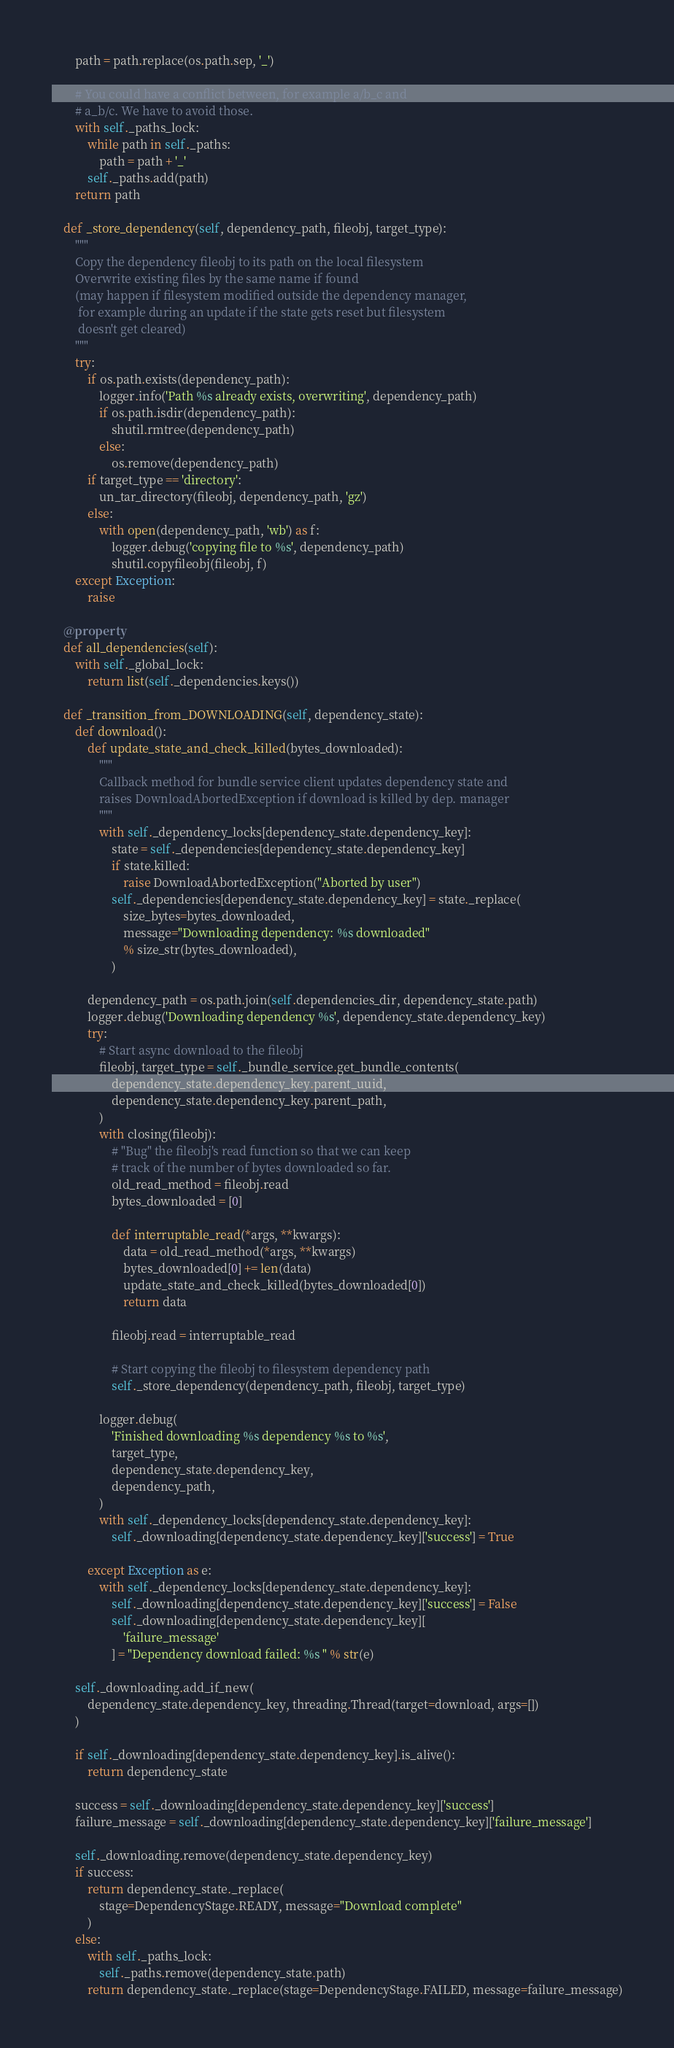<code> <loc_0><loc_0><loc_500><loc_500><_Python_>        path = path.replace(os.path.sep, '_')

        # You could have a conflict between, for example a/b_c and
        # a_b/c. We have to avoid those.
        with self._paths_lock:
            while path in self._paths:
                path = path + '_'
            self._paths.add(path)
        return path

    def _store_dependency(self, dependency_path, fileobj, target_type):
        """
        Copy the dependency fileobj to its path on the local filesystem
        Overwrite existing files by the same name if found
        (may happen if filesystem modified outside the dependency manager,
         for example during an update if the state gets reset but filesystem
         doesn't get cleared)
        """
        try:
            if os.path.exists(dependency_path):
                logger.info('Path %s already exists, overwriting', dependency_path)
                if os.path.isdir(dependency_path):
                    shutil.rmtree(dependency_path)
                else:
                    os.remove(dependency_path)
            if target_type == 'directory':
                un_tar_directory(fileobj, dependency_path, 'gz')
            else:
                with open(dependency_path, 'wb') as f:
                    logger.debug('copying file to %s', dependency_path)
                    shutil.copyfileobj(fileobj, f)
        except Exception:
            raise

    @property
    def all_dependencies(self):
        with self._global_lock:
            return list(self._dependencies.keys())

    def _transition_from_DOWNLOADING(self, dependency_state):
        def download():
            def update_state_and_check_killed(bytes_downloaded):
                """
                Callback method for bundle service client updates dependency state and
                raises DownloadAbortedException if download is killed by dep. manager
                """
                with self._dependency_locks[dependency_state.dependency_key]:
                    state = self._dependencies[dependency_state.dependency_key]
                    if state.killed:
                        raise DownloadAbortedException("Aborted by user")
                    self._dependencies[dependency_state.dependency_key] = state._replace(
                        size_bytes=bytes_downloaded,
                        message="Downloading dependency: %s downloaded"
                        % size_str(bytes_downloaded),
                    )

            dependency_path = os.path.join(self.dependencies_dir, dependency_state.path)
            logger.debug('Downloading dependency %s', dependency_state.dependency_key)
            try:
                # Start async download to the fileobj
                fileobj, target_type = self._bundle_service.get_bundle_contents(
                    dependency_state.dependency_key.parent_uuid,
                    dependency_state.dependency_key.parent_path,
                )
                with closing(fileobj):
                    # "Bug" the fileobj's read function so that we can keep
                    # track of the number of bytes downloaded so far.
                    old_read_method = fileobj.read
                    bytes_downloaded = [0]

                    def interruptable_read(*args, **kwargs):
                        data = old_read_method(*args, **kwargs)
                        bytes_downloaded[0] += len(data)
                        update_state_and_check_killed(bytes_downloaded[0])
                        return data

                    fileobj.read = interruptable_read

                    # Start copying the fileobj to filesystem dependency path
                    self._store_dependency(dependency_path, fileobj, target_type)

                logger.debug(
                    'Finished downloading %s dependency %s to %s',
                    target_type,
                    dependency_state.dependency_key,
                    dependency_path,
                )
                with self._dependency_locks[dependency_state.dependency_key]:
                    self._downloading[dependency_state.dependency_key]['success'] = True

            except Exception as e:
                with self._dependency_locks[dependency_state.dependency_key]:
                    self._downloading[dependency_state.dependency_key]['success'] = False
                    self._downloading[dependency_state.dependency_key][
                        'failure_message'
                    ] = "Dependency download failed: %s " % str(e)

        self._downloading.add_if_new(
            dependency_state.dependency_key, threading.Thread(target=download, args=[])
        )

        if self._downloading[dependency_state.dependency_key].is_alive():
            return dependency_state

        success = self._downloading[dependency_state.dependency_key]['success']
        failure_message = self._downloading[dependency_state.dependency_key]['failure_message']

        self._downloading.remove(dependency_state.dependency_key)
        if success:
            return dependency_state._replace(
                stage=DependencyStage.READY, message="Download complete"
            )
        else:
            with self._paths_lock:
                self._paths.remove(dependency_state.path)
            return dependency_state._replace(stage=DependencyStage.FAILED, message=failure_message)
</code> 